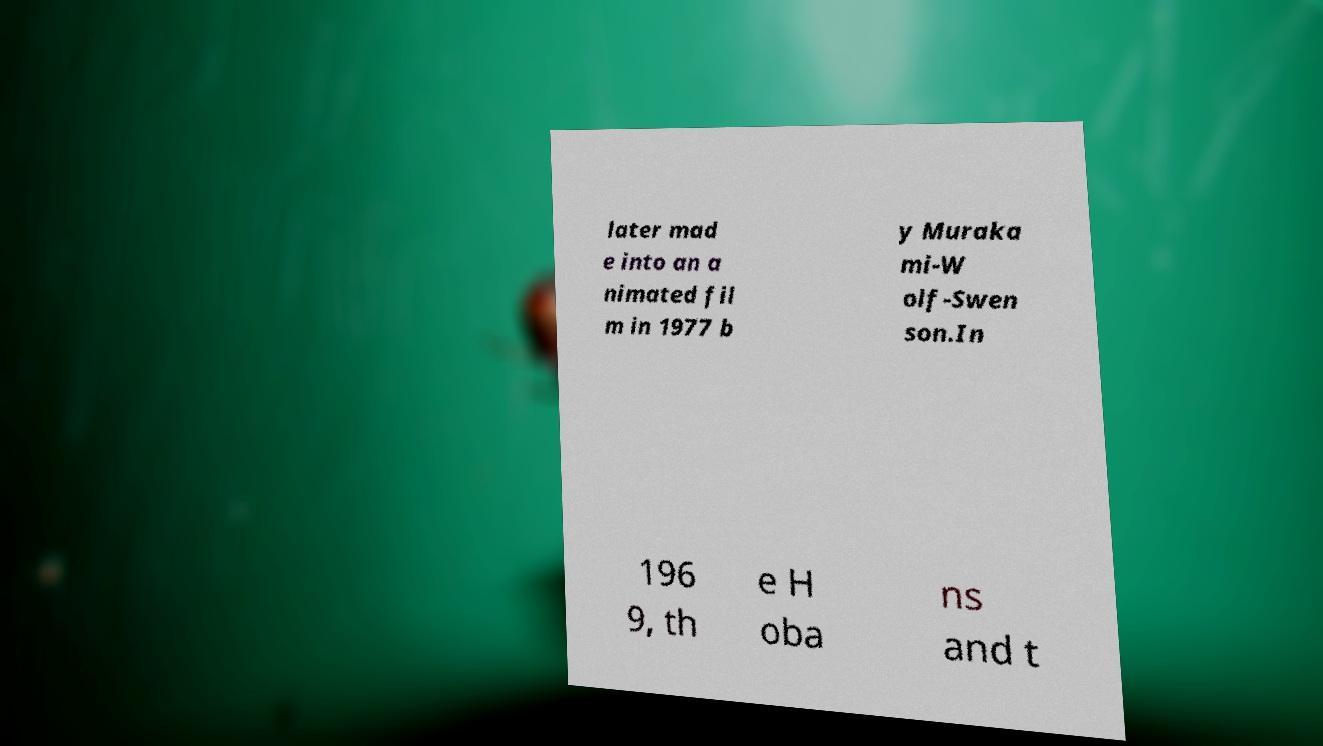Please read and relay the text visible in this image. What does it say? later mad e into an a nimated fil m in 1977 b y Muraka mi-W olf-Swen son.In 196 9, th e H oba ns and t 